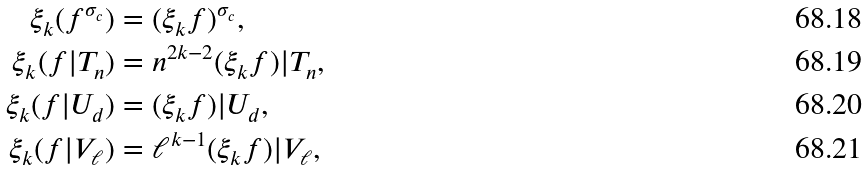Convert formula to latex. <formula><loc_0><loc_0><loc_500><loc_500>\xi _ { k } ( f ^ { \sigma _ { c } } ) & = ( \xi _ { k } f ) ^ { \sigma _ { c } } , \\ \xi _ { k } ( f | T _ { n } ) & = n ^ { 2 k - 2 } ( \xi _ { k } f ) | T _ { n } , \\ \xi _ { k } ( f | U _ { d } ) & = ( \xi _ { k } f ) | U _ { d } , \\ \xi _ { k } ( f | V _ { \ell } ) & = \ell ^ { k - 1 } ( \xi _ { k } f ) | V _ { \ell } ,</formula> 